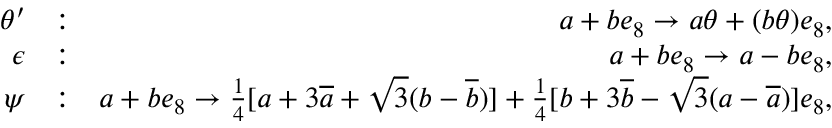Convert formula to latex. <formula><loc_0><loc_0><loc_500><loc_500>\begin{array} { r l r } { \theta ^ { \prime } } & { \colon } & { a + b e _ { 8 } \rightarrow a \theta + ( b \theta ) e _ { 8 } , } \\ { \epsilon } & { \colon } & { a + b e _ { 8 } \rightarrow a - b e _ { 8 } , } \\ { \psi } & { \colon } & { a + b e _ { 8 } \rightarrow \frac { 1 } { 4 } [ a + 3 \overline { a } + \sqrt { 3 } ( b - \overline { b } ) ] + \frac { 1 } { 4 } [ b + 3 \overline { b } - \sqrt { 3 } ( a - \overline { a } ) ] e _ { 8 } , } \end{array}</formula> 